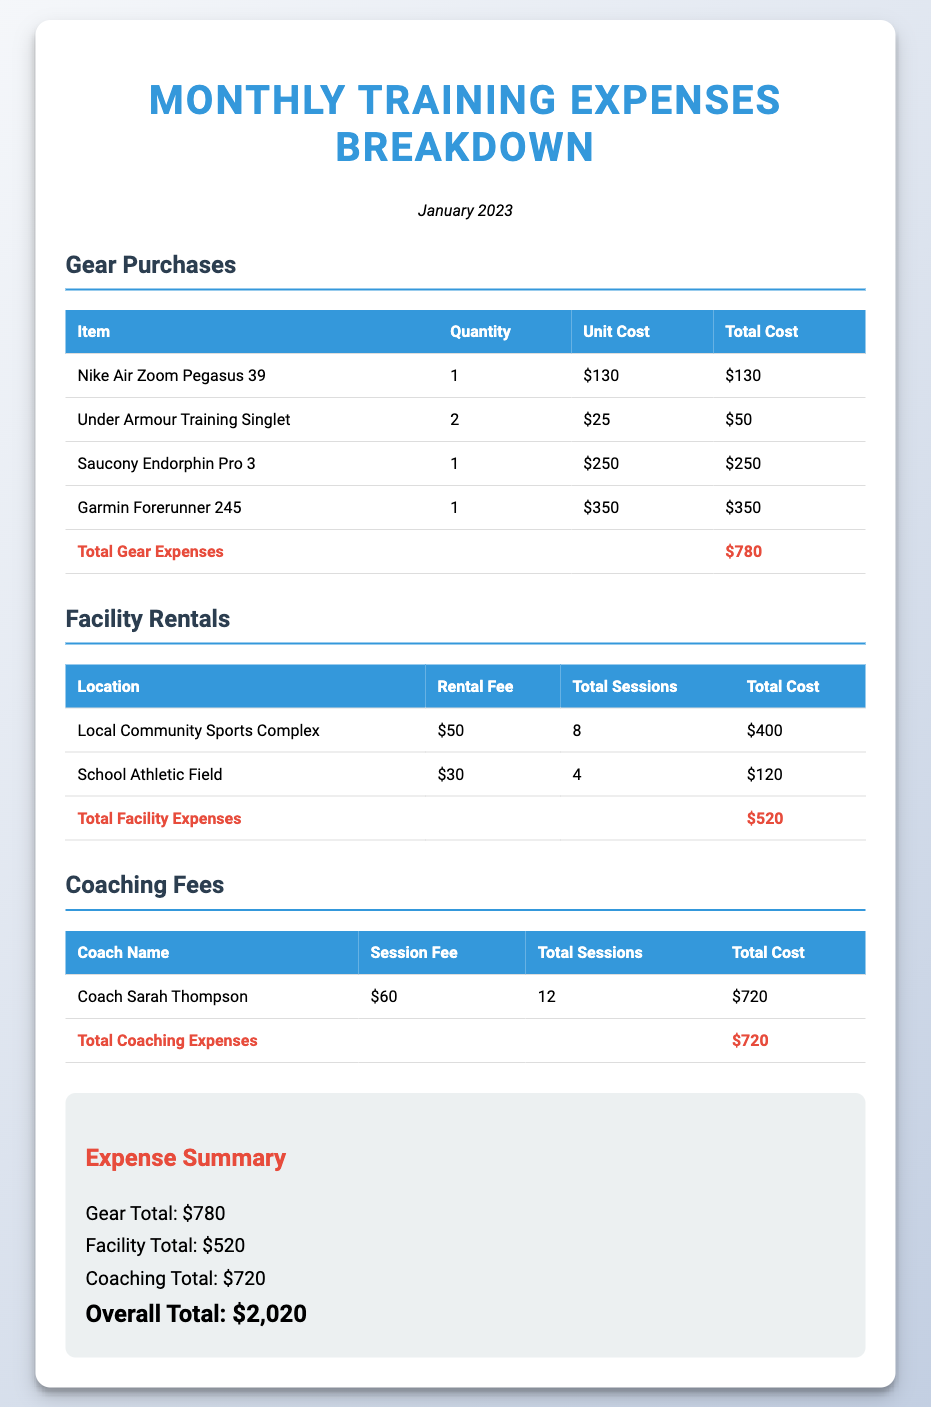what is the total gear expenses? The total gear expenses are listed at the bottom of the gear purchases table.
Answer: $780 how many sessions were held at the Local Community Sports Complex? The Local Community Sports Complex had a total of 8 sessions listed in the table.
Answer: 8 who is the coach that provided the most coaching sessions? There is only one coach listed, and thus they are the one who provided the most sessions.
Answer: Coach Sarah Thompson what is the rental fee for the School Athletic Field? The rental fee for the School Athletic Field is shown in the facility rentals table.
Answer: $30 what is the total coaching expenses? The total coaching expenses are calculated at the bottom of the coaching fees table.
Answer: $720 how much was spent on facility rentals? The total facility expenses can be found at the bottom of the facility rentals table.
Answer: $520 what is the overall total for all expenses? The overall total is summarized at the bottom of the Expense Summary section.
Answer: $2,020 how many Nike Air Zoom Pegasus 39 were purchased? The quantity of Nike Air Zoom Pegasus 39 is specified in the gear purchases table.
Answer: 1 which gear item had the highest cost? The gear item with the highest cost is identified in the gear purchases table.
Answer: Garmin Forerunner 245 